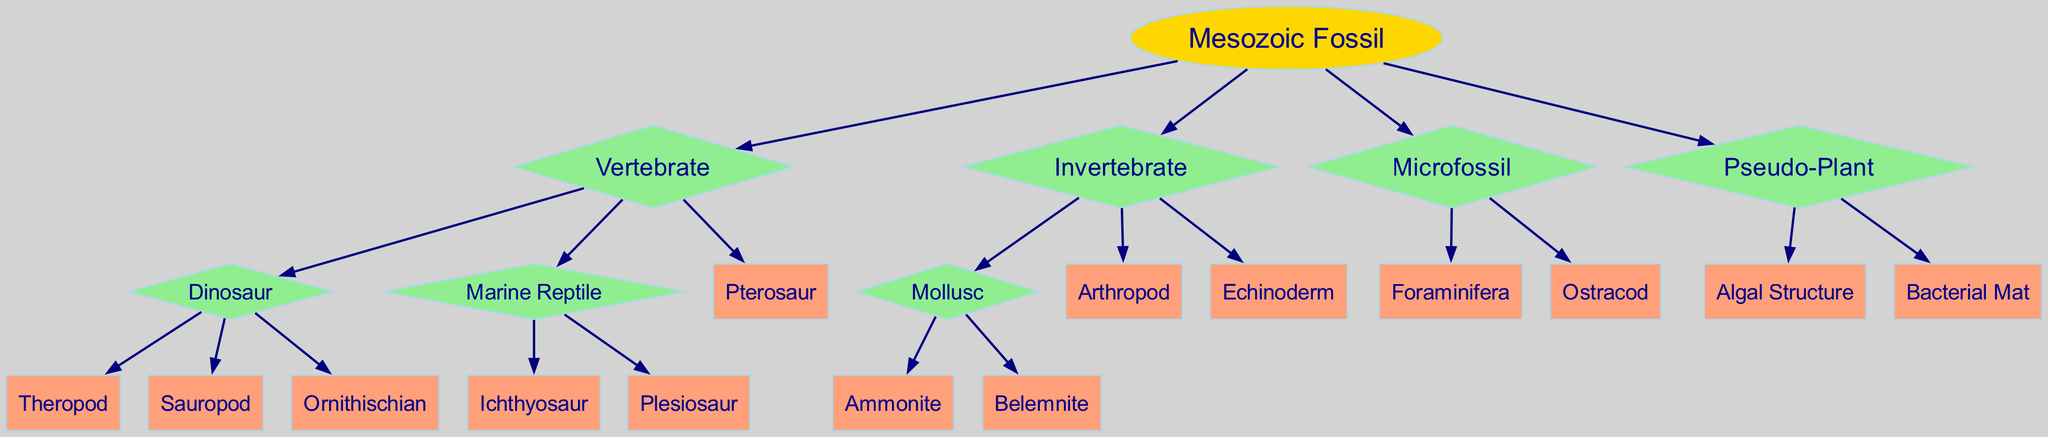What is the root node of the diagram? The root node is labeled "Mesozoic Fossil," and it is the starting point of the classification tree.
Answer: Mesozoic Fossil How many main branches does the diagram have? The diagram has four main branches emerging from the root node: Vertebrate, Invertebrate, Microfossil, and Pseudo-Plant.
Answer: 4 Which group does the "Theropod" belong to? "Theropod" is listed as a child under the "Dinosaur" category, which itself is a child of the "Vertebrate" branch.
Answer: Dinosaur What type of node is "Ichthyosaur"? "Ichthyosaur" is a terminal node and belongs to the category "Marine Reptile," which is under the "Vertebrate" branch, indicating it is a type of vertebrate fossil.
Answer: Rectangle How many children does the "Mollusc" node have? The "Mollusc" node has two children: "Ammonite" and "Belemnite." Thus, counting both, it has a total of two children.
Answer: 2 Which categories are classified under "Invertebrate"? The "Invertebrate" branch contains three categories: "Mollusc," "Arthropod," and "Echinoderm."
Answer: Mollusc, Arthropod, Echinoderm What distinguishes "Pseudo-Plant" fossils from actual plants? "Pseudo-Plant" includes structures like "Algal Structure" and "Bacterial Mat," which are misunderstood to be plants but are actually non-plant organisms from the Mesozoic era.
Answer: Non-plant Which type of fossil is the "Ammonite"? The "Ammonite" is a type of fossil categorized under "Mollusc," which is a subset of "Invertebrate."
Answer: Mollusc What is the relationship between "Pterosaur" and "Marine Reptile"? "Pterosaur" is a sibling node to "Marine Reptile" under the shared parent "Vertebrate," meaning both belong to the same higher category but are different groups of fossils.
Answer: Sibling nodes 